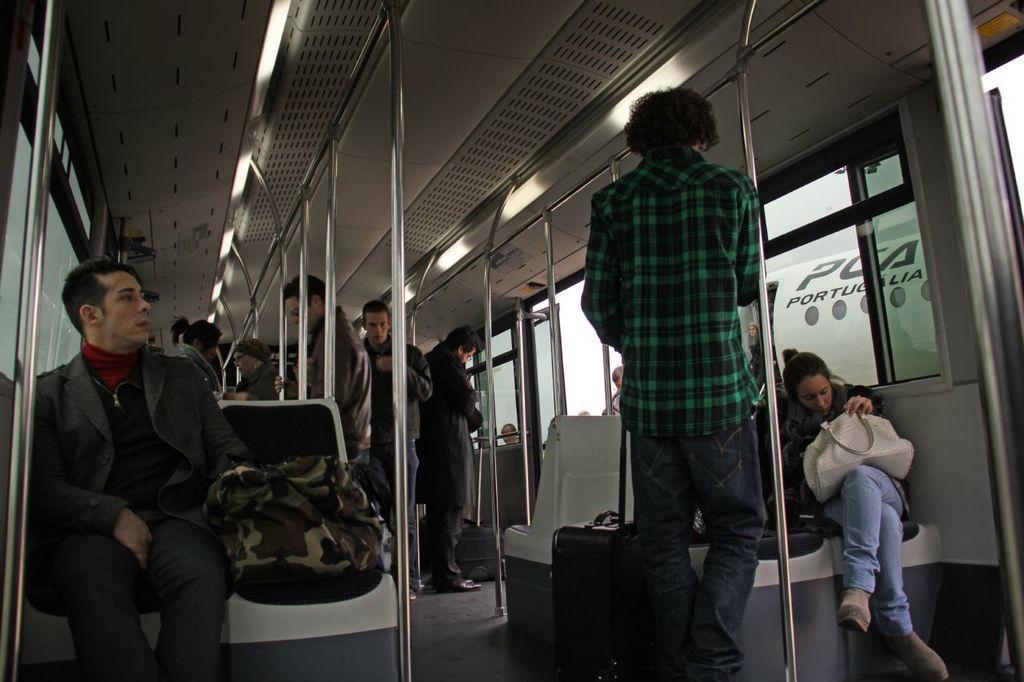Can you describe this image briefly? This is the inside picture of the train. In this image there are a few people sitting on the chairs and some other people are standing in the train. 